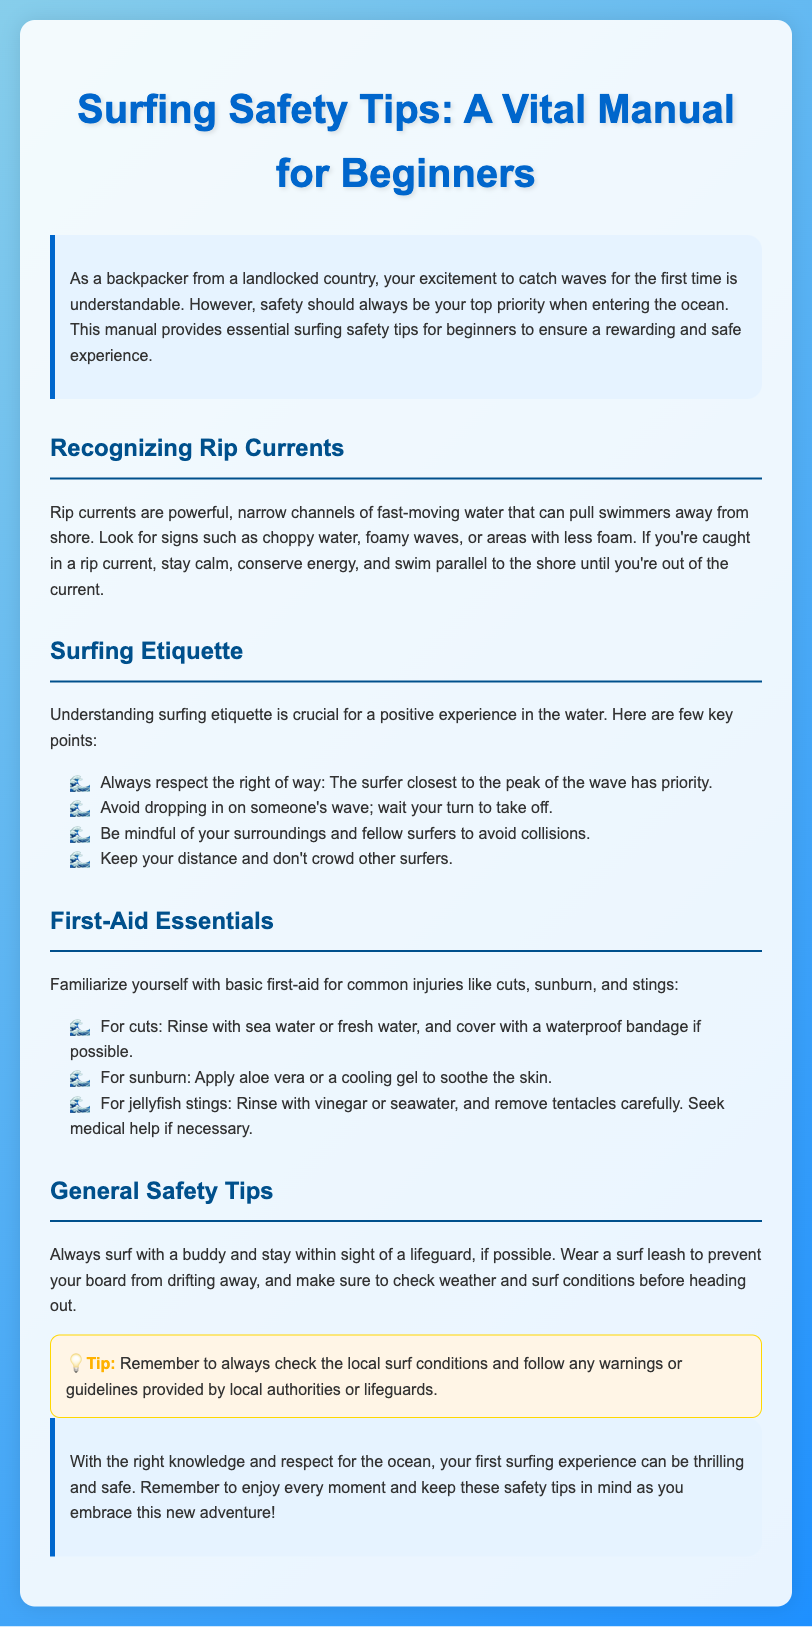What are rip currents? Rip currents are powerful, narrow channels of fast-moving water that can pull swimmers away from shore.
Answer: Powerful, narrow channels of fast-moving water What should you do if caught in a rip current? The document advises to stay calm, conserve energy, and swim parallel to the shore until you're out of the current.
Answer: Swim parallel to the shore What is the surfer's priority at the wave peak? The surfer closest to the peak of the wave has priority.
Answer: The surfer closest to the peak What basic first-aid should be applied for cuts? For cuts, rinse with sea water or fresh water, and cover with a waterproof bandage if possible.
Answer: Rinse and cover with a waterproof bandage What is a key precaution before surfing? Always surf with a buddy and stay within sight of a lifeguard, if possible.
Answer: Surf with a buddy What should be done for sunburn? Apply aloe vera or a cooling gel to soothe the skin.
Answer: Apply aloe vera What color is the title of the manual? The title of the manual is in a vibrant blue color.
Answer: Blue How can you recognize areas with rip currents? Look for signs such as choppy water, foamy waves, or areas with less foam.
Answer: Choppy water, foamy waves, less foam What is the publication type of this document? This document is a manual aimed at beginners on surfing safety tips.
Answer: Manual 